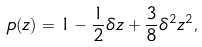Convert formula to latex. <formula><loc_0><loc_0><loc_500><loc_500>p ( z ) = 1 - \frac { 1 } { 2 } \delta z + \frac { 3 } { 8 } \delta ^ { 2 } z ^ { 2 } ,</formula> 